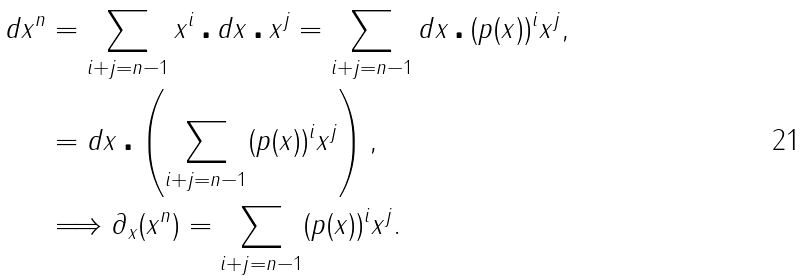<formula> <loc_0><loc_0><loc_500><loc_500>d x ^ { n } & = \sum _ { i + j = n - 1 } x ^ { i } \centerdot d x \centerdot x ^ { j } = \sum _ { i + j = n - 1 } d x \centerdot ( p ( x ) ) ^ { i } x ^ { j } , \\ & = d x \centerdot \left ( \sum _ { i + j = n - 1 } ( p ( x ) ) ^ { i } x ^ { j } \right ) , \\ & \Longrightarrow \partial _ { x } ( x ^ { n } ) = \sum _ { i + j = n - 1 } ( p ( x ) ) ^ { i } x ^ { j } .</formula> 